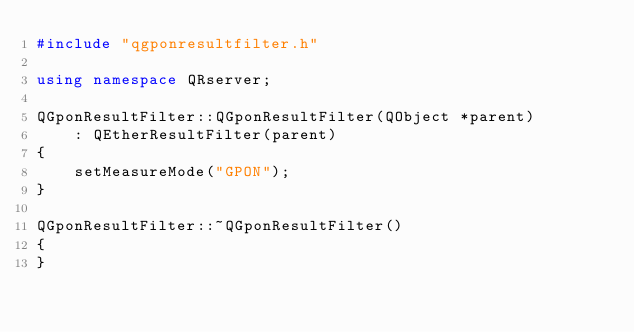Convert code to text. <code><loc_0><loc_0><loc_500><loc_500><_C++_>#include "qgponresultfilter.h"

using namespace QRserver;

QGponResultFilter::QGponResultFilter(QObject *parent)
    : QEtherResultFilter(parent)
{
    setMeasureMode("GPON");
}

QGponResultFilter::~QGponResultFilter()
{
}
</code> 